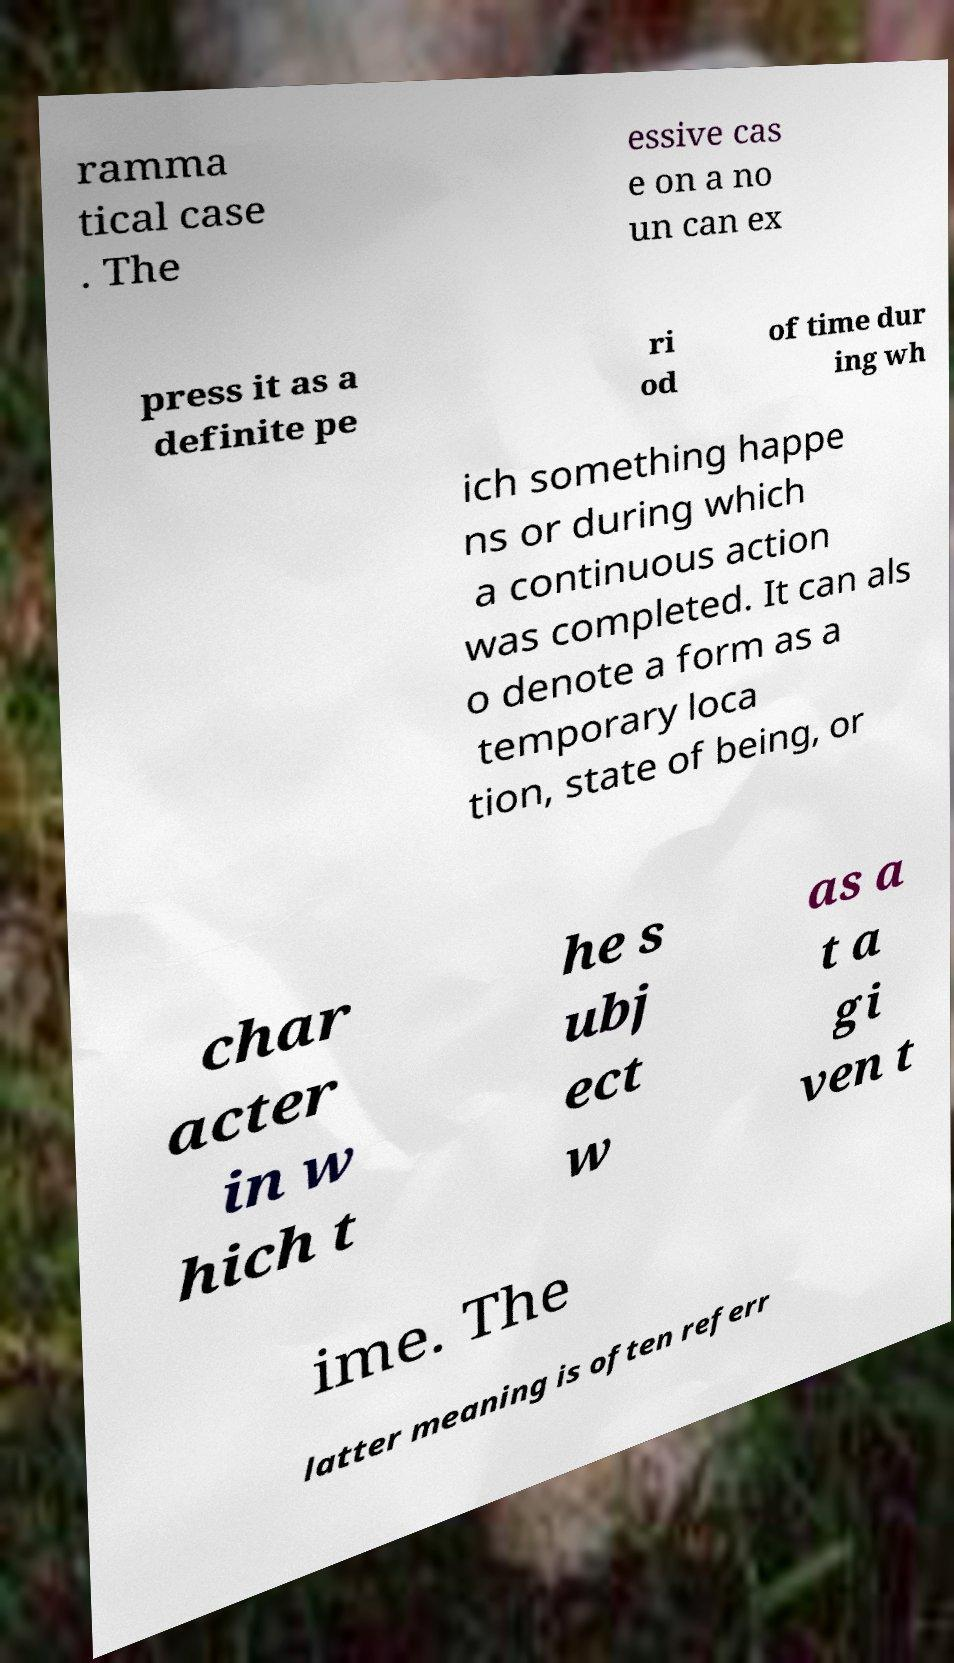Can you read and provide the text displayed in the image?This photo seems to have some interesting text. Can you extract and type it out for me? ramma tical case . The essive cas e on a no un can ex press it as a definite pe ri od of time dur ing wh ich something happe ns or during which a continuous action was completed. It can als o denote a form as a temporary loca tion, state of being, or char acter in w hich t he s ubj ect w as a t a gi ven t ime. The latter meaning is often referr 